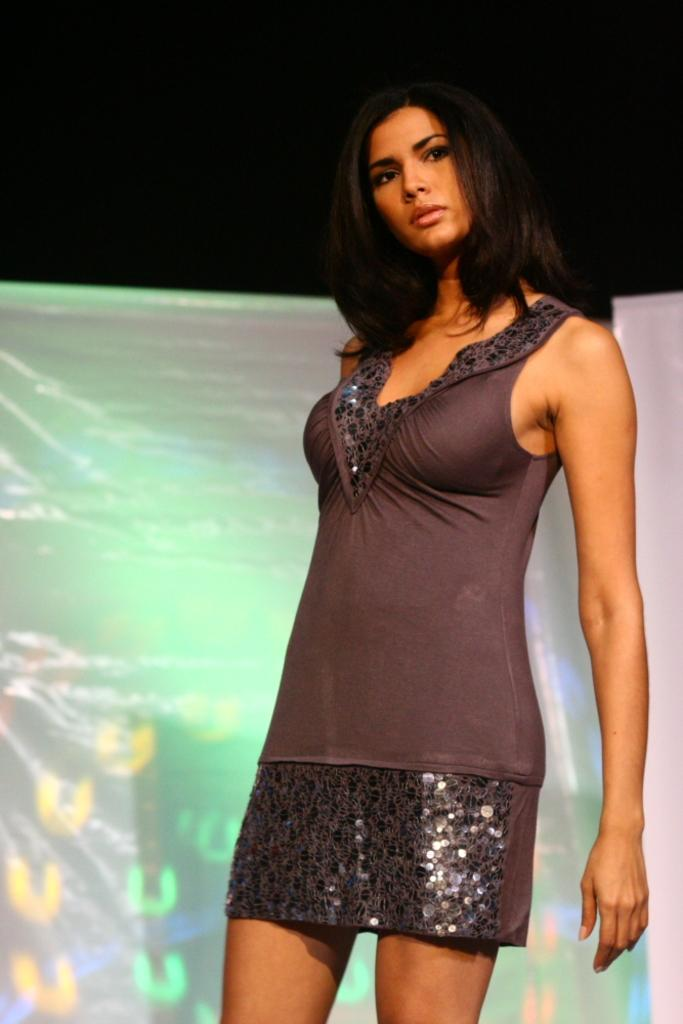Who is the main subject in the image? There is a woman in the image. What is the woman doing in the image? The woman is standing and posing for the photo. What can be seen in the background of the image? There are visuals being displayed on a screen in the background of the image. What type of feeling is the woman experiencing in the image? There is no indication of the woman's feelings in the image, as we cannot see her facial expression or body language. 